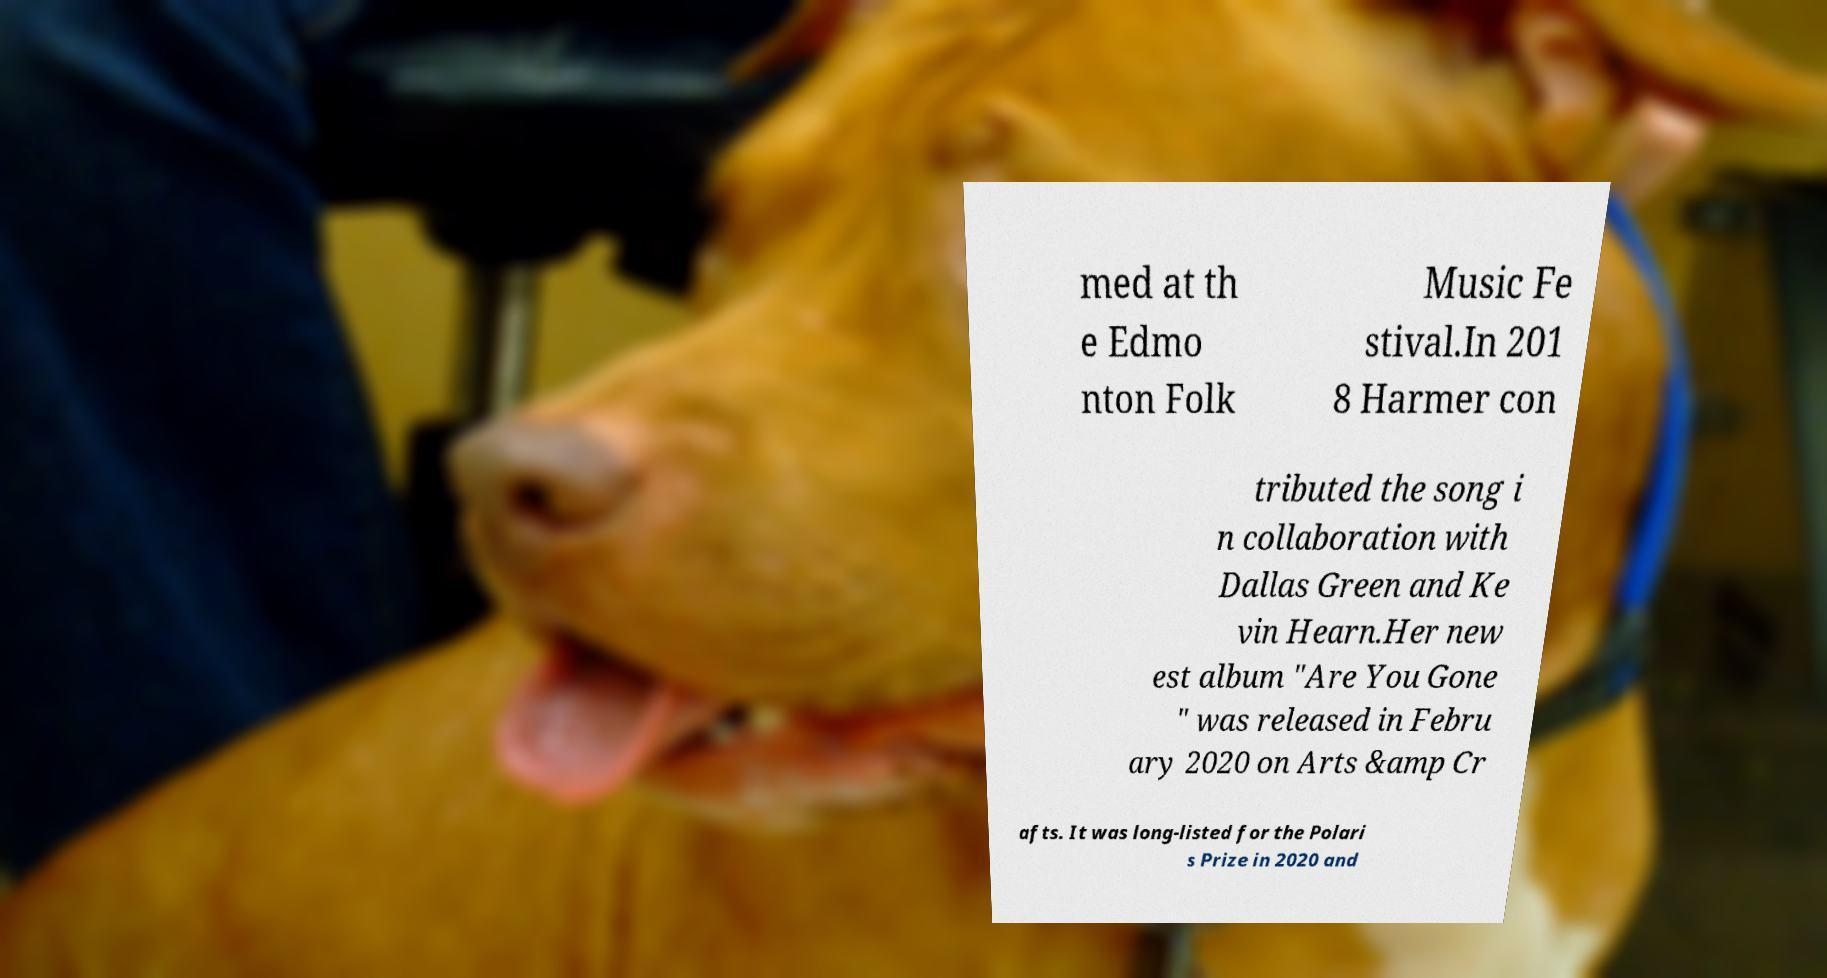I need the written content from this picture converted into text. Can you do that? med at th e Edmo nton Folk Music Fe stival.In 201 8 Harmer con tributed the song i n collaboration with Dallas Green and Ke vin Hearn.Her new est album "Are You Gone " was released in Febru ary 2020 on Arts &amp Cr afts. It was long-listed for the Polari s Prize in 2020 and 